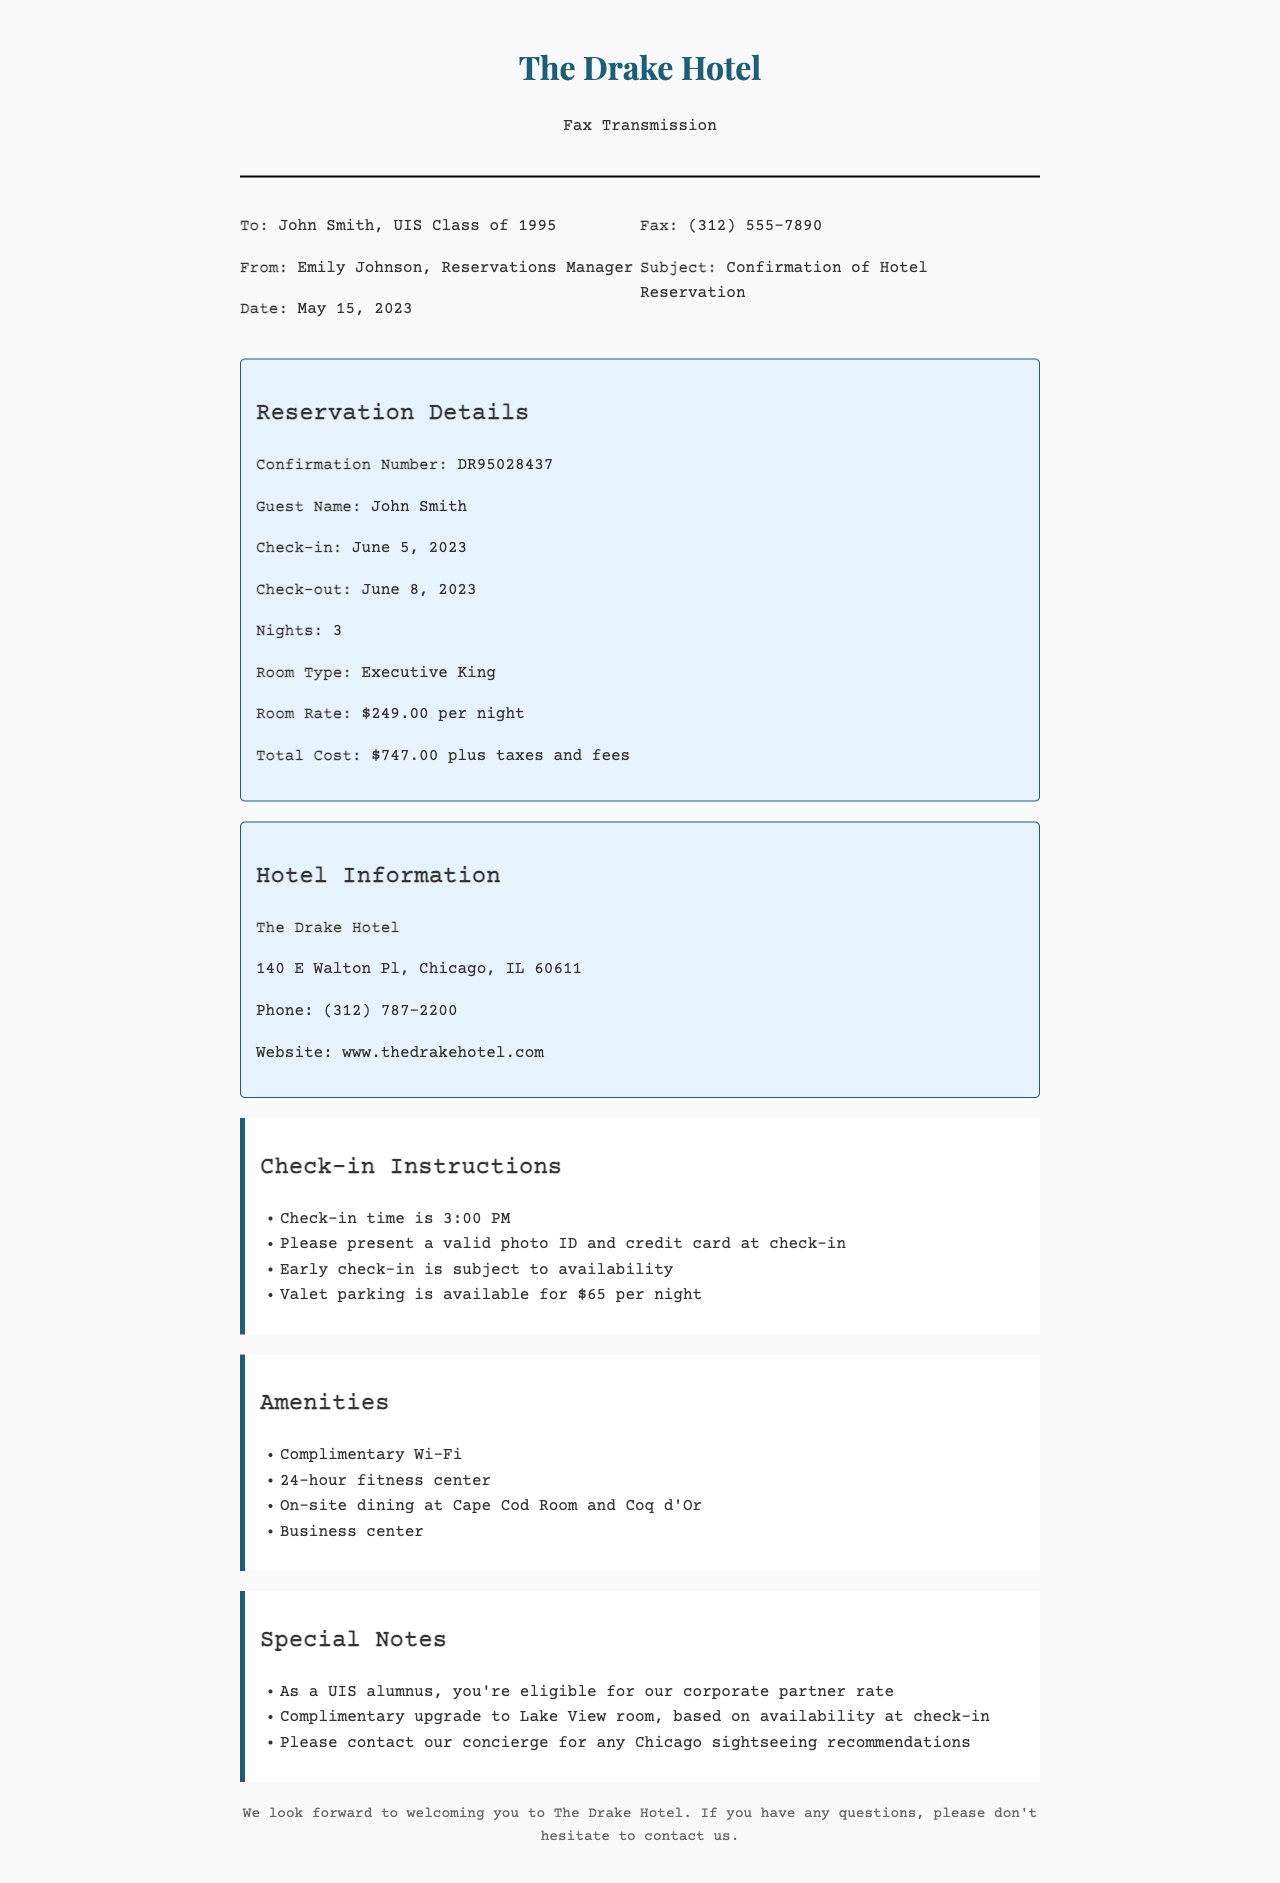What is the confirmation number? The confirmation number is found in the reservation details section of the fax.
Answer: DR95028437 What is the check-in date? The check-in date is specified in the reservation details of the document.
Answer: June 5, 2023 What type of room is reserved? The type of room is mentioned in the reservation details section.
Answer: Executive King How many nights will the guest be staying? The number of nights is listed in the reservation details.
Answer: 3 What is the total cost before taxes and fees? The total cost is provided in the reservation details section of the fax.
Answer: $747.00 What time is check-in? The check-in time is included in the check-in instructions.
Answer: 3:00 PM What amenities are offered at the hotel? The amenities section details the available services at the hotel.
Answer: Complimentary Wi-Fi Who should be contacted for sightseeing recommendations? The special notes section mentions who to contact for recommendations.
Answer: Concierge What is the address of The Drake Hotel? The address is provided in the hotel information section of the fax.
Answer: 140 E Walton Pl, Chicago, IL 60611 